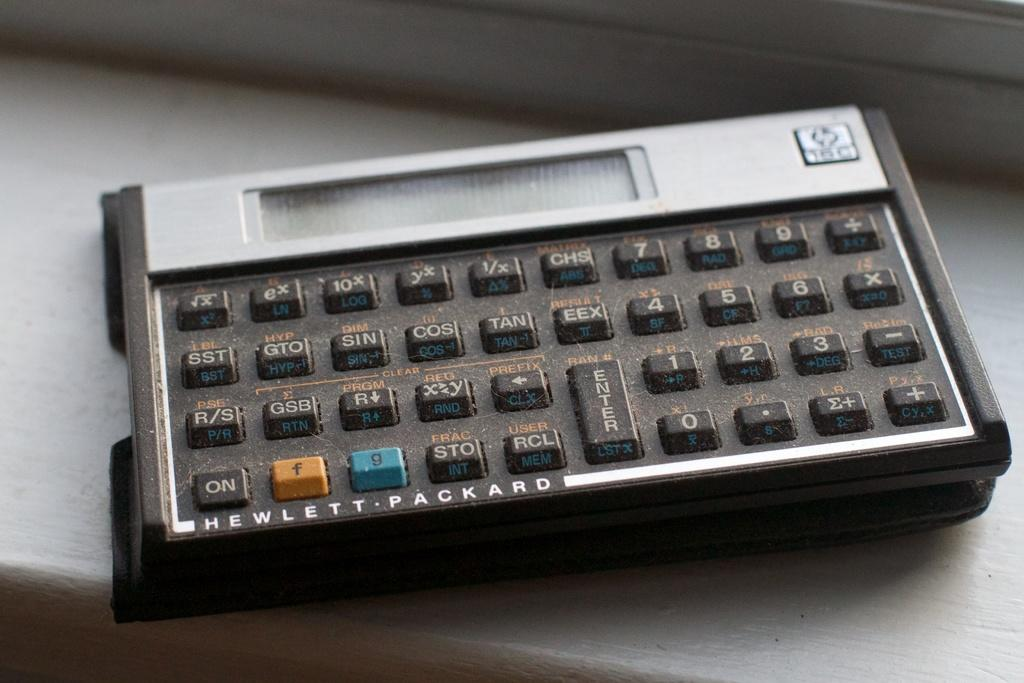<image>
Describe the image concisely. A small, dusty button panel is made by Hewlett-Packard. 